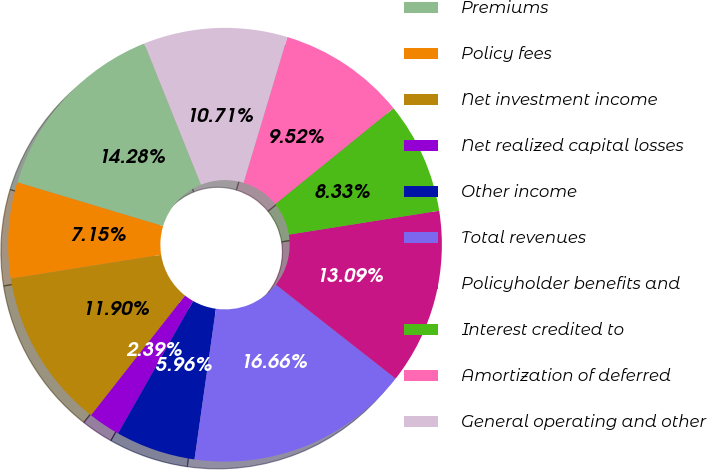Convert chart. <chart><loc_0><loc_0><loc_500><loc_500><pie_chart><fcel>Premiums<fcel>Policy fees<fcel>Net investment income<fcel>Net realized capital losses<fcel>Other income<fcel>Total revenues<fcel>Policyholder benefits and<fcel>Interest credited to<fcel>Amortization of deferred<fcel>General operating and other<nl><fcel>14.28%<fcel>7.15%<fcel>11.9%<fcel>2.39%<fcel>5.96%<fcel>16.66%<fcel>13.09%<fcel>8.33%<fcel>9.52%<fcel>10.71%<nl></chart> 